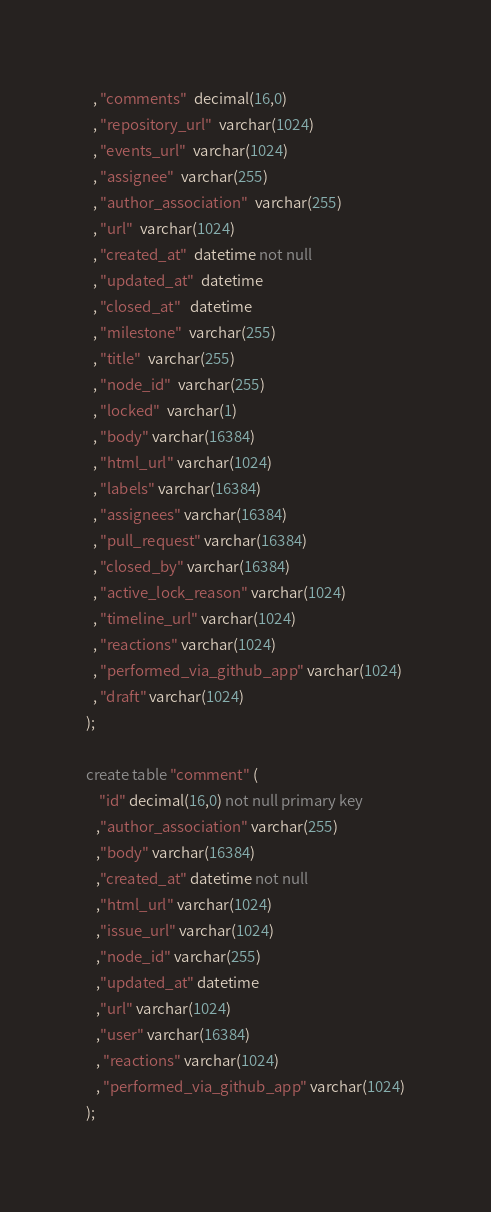<code> <loc_0><loc_0><loc_500><loc_500><_SQL_>  , "comments"  decimal(16,0)
  , "repository_url"  varchar(1024)
  , "events_url"  varchar(1024)
  , "assignee"  varchar(255)
  , "author_association"  varchar(255)
  , "url"  varchar(1024)
  , "created_at"  datetime not null
  , "updated_at"  datetime
  , "closed_at"   datetime
  , "milestone"  varchar(255)
  , "title"  varchar(255)
  , "node_id"  varchar(255)
  , "locked"  varchar(1)
  , "body" varchar(16384)
  , "html_url" varchar(1024)
  , "labels" varchar(16384)
  , "assignees" varchar(16384)
  , "pull_request" varchar(16384)
  , "closed_by" varchar(16384)
  , "active_lock_reason" varchar(1024)
  , "timeline_url" varchar(1024)
  , "reactions" varchar(1024)
  , "performed_via_github_app" varchar(1024)
  , "draft" varchar(1024)
);

create table "comment" (
    "id" decimal(16,0) not null primary key
   ,"author_association" varchar(255)
   ,"body" varchar(16384)
   ,"created_at" datetime not null
   ,"html_url" varchar(1024)
   ,"issue_url" varchar(1024)
   ,"node_id" varchar(255)
   ,"updated_at" datetime
   ,"url" varchar(1024)
   ,"user" varchar(16384)
   , "reactions" varchar(1024)
   , "performed_via_github_app" varchar(1024)
);
</code> 